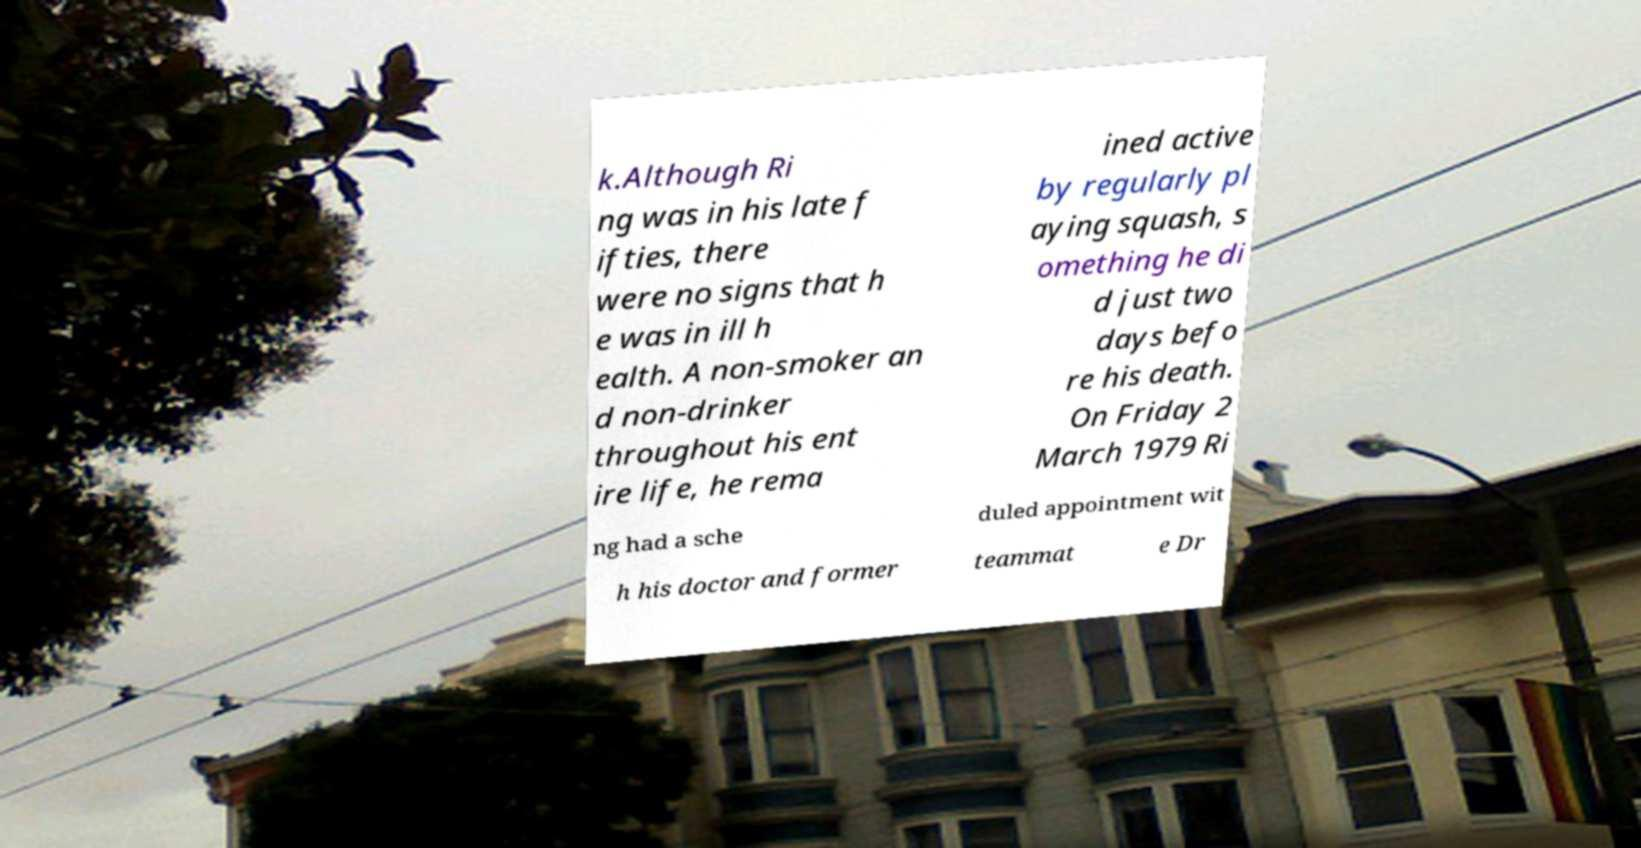Could you assist in decoding the text presented in this image and type it out clearly? k.Although Ri ng was in his late f ifties, there were no signs that h e was in ill h ealth. A non-smoker an d non-drinker throughout his ent ire life, he rema ined active by regularly pl aying squash, s omething he di d just two days befo re his death. On Friday 2 March 1979 Ri ng had a sche duled appointment wit h his doctor and former teammat e Dr 